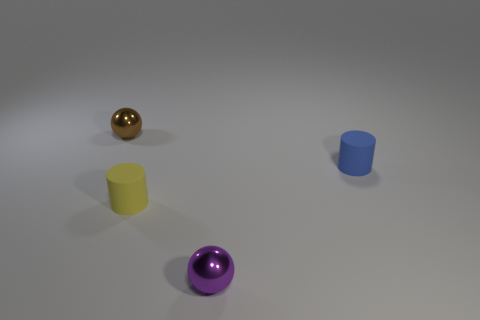Subtract 2 cylinders. How many cylinders are left? 0 Add 4 tiny purple rubber balls. How many objects exist? 8 Add 3 yellow matte cylinders. How many yellow matte cylinders are left? 4 Add 3 brown metallic spheres. How many brown metallic spheres exist? 4 Subtract all purple spheres. How many spheres are left? 1 Subtract 0 green spheres. How many objects are left? 4 Subtract all blue spheres. Subtract all yellow cubes. How many spheres are left? 2 Subtract all purple balls. How many brown cylinders are left? 0 Subtract all gray metal cylinders. Subtract all small rubber cylinders. How many objects are left? 2 